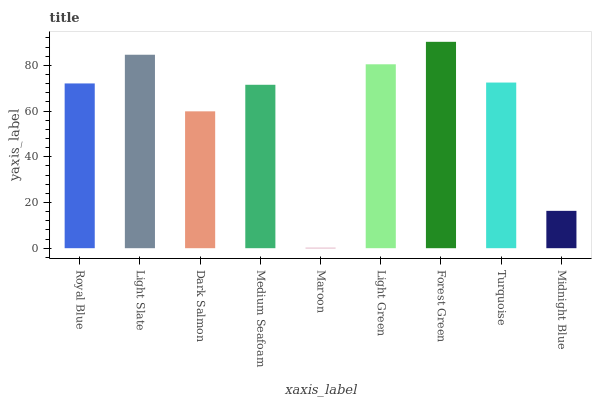Is Light Slate the minimum?
Answer yes or no. No. Is Light Slate the maximum?
Answer yes or no. No. Is Light Slate greater than Royal Blue?
Answer yes or no. Yes. Is Royal Blue less than Light Slate?
Answer yes or no. Yes. Is Royal Blue greater than Light Slate?
Answer yes or no. No. Is Light Slate less than Royal Blue?
Answer yes or no. No. Is Royal Blue the high median?
Answer yes or no. Yes. Is Royal Blue the low median?
Answer yes or no. Yes. Is Maroon the high median?
Answer yes or no. No. Is Forest Green the low median?
Answer yes or no. No. 